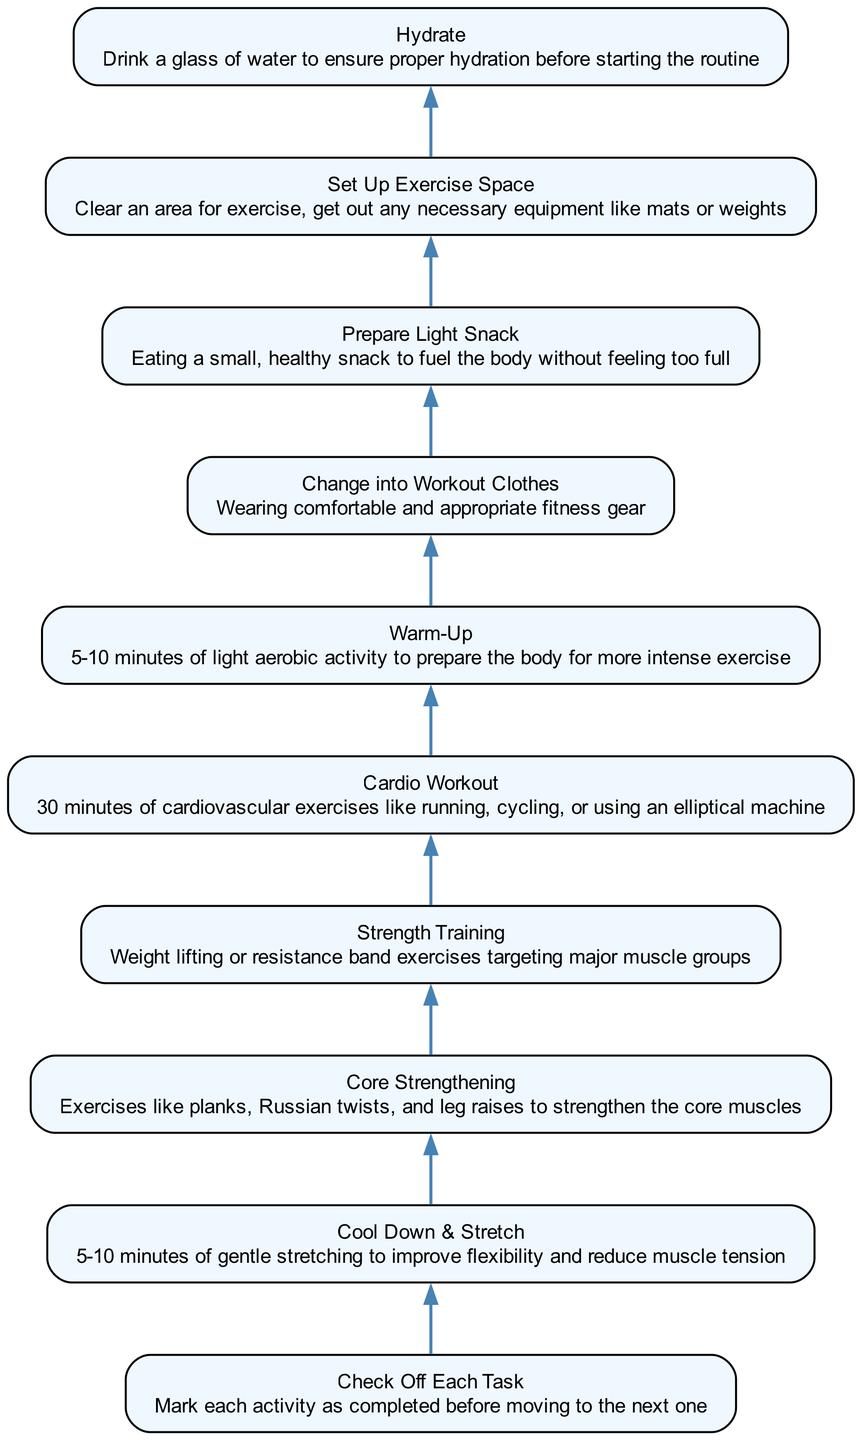What is the first task in the checklist? The first task in the checklist, which is located at the bottom of the diagram, is "Check Off Each Task". It is the task that initiates the daily fitness routine.
Answer: Check Off Each Task How many tasks are included in the checklist? The checklist consists of ten tasks, which can be counted in the diagram nodes. Each task is represented as a separate node from bottom to top.
Answer: 10 What follows after "Cool Down & Stretch" in the flow? The task that follows "Cool Down & Stretch" directly in the flow is "Core Strengthening", as indicated by the connecting edge leading upward from "Cool Down & Stretch".
Answer: Core Strengthening What is the last task performed before "Hydrate"? The last task that must be completed before "Hydrate" is "Set Up Exercise Space." This can be traced by following the upward flow in the diagram.
Answer: Set Up Exercise Space List the tasks in the checklist in order from top to bottom. The order of tasks from top to bottom in the checklist is: Hydrate, Prepare Light Snack, Change into Workout Clothes, Warm-Up, Cardio Workout, Strength Training, Core Strengthening, Cool Down & Stretch, Check Off Each Task.
Answer: Hydrate, Prepare Light Snack, Change into Workout Clothes, Warm-Up, Cardio Workout, Strength Training, Core Strengthening, Cool Down & Stretch, Check Off Each Task Which task comes immediately before "Strength Training"? The task immediately before "Strength Training" in the flowchart is "Core Strengthening". The flow indicates this relationship by connecting the two nodes directly.
Answer: Core Strengthening 